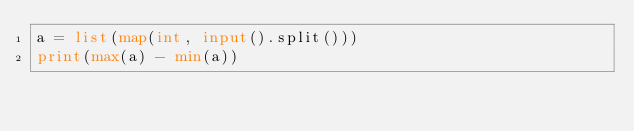<code> <loc_0><loc_0><loc_500><loc_500><_Python_>a = list(map(int, input().split()))
print(max(a) - min(a))
</code> 